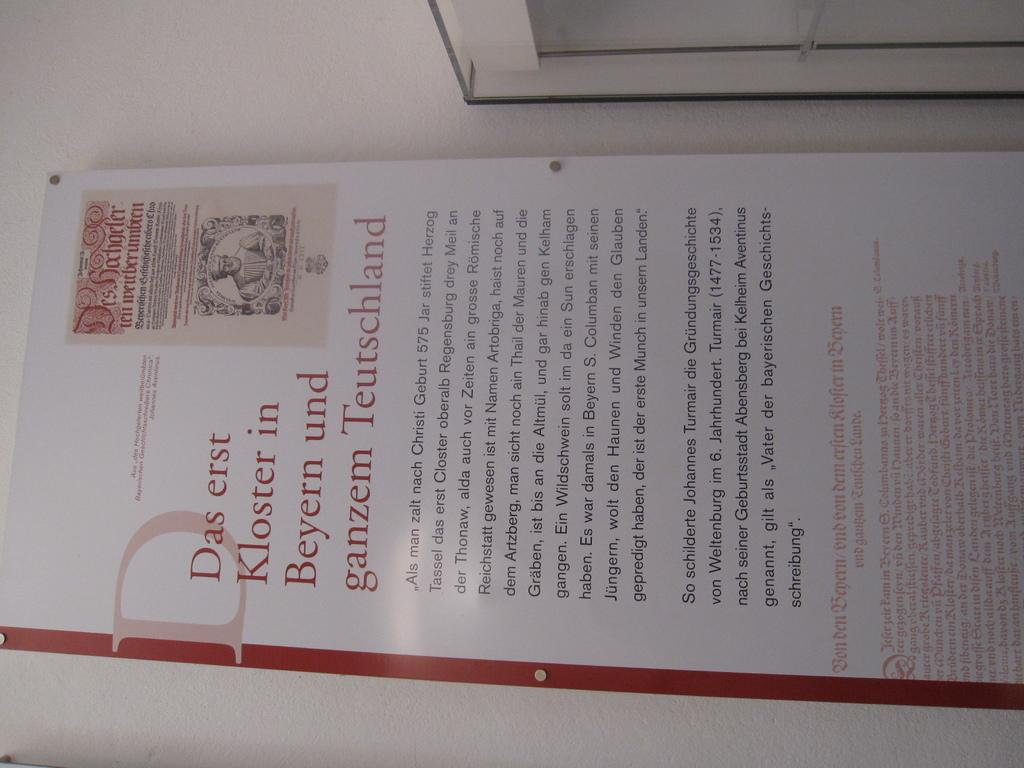Provide a one-sentence caption for the provided image. A sign mentions Kloster in Beyern, written in red text. 